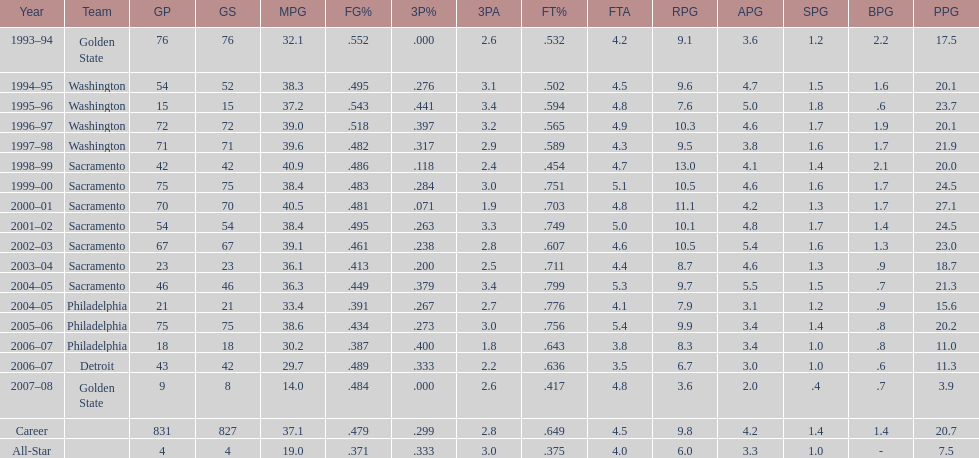How many seasons did webber average over 20 points per game (ppg)? 11. 